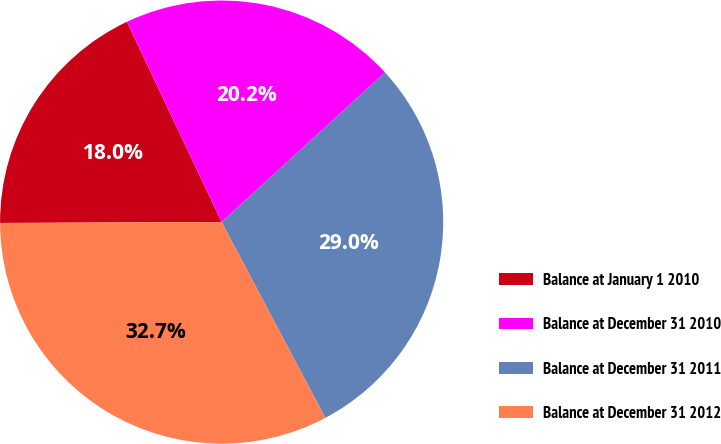Convert chart. <chart><loc_0><loc_0><loc_500><loc_500><pie_chart><fcel>Balance at January 1 2010<fcel>Balance at December 31 2010<fcel>Balance at December 31 2011<fcel>Balance at December 31 2012<nl><fcel>18.03%<fcel>20.23%<fcel>29.05%<fcel>32.69%<nl></chart> 